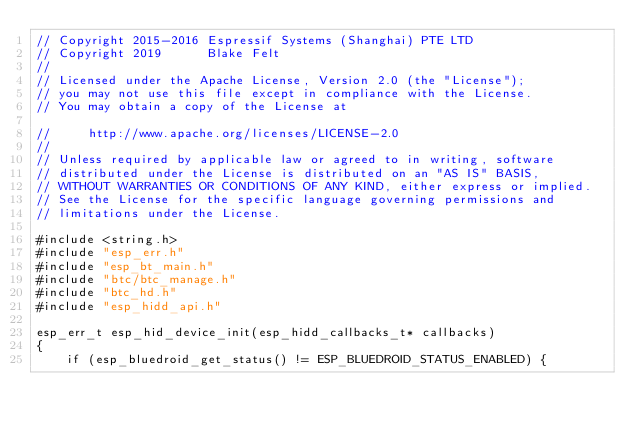Convert code to text. <code><loc_0><loc_0><loc_500><loc_500><_C_>// Copyright 2015-2016 Espressif Systems (Shanghai) PTE LTD
// Copyright 2019      Blake Felt
//
// Licensed under the Apache License, Version 2.0 (the "License");
// you may not use this file except in compliance with the License.
// You may obtain a copy of the License at

//     http://www.apache.org/licenses/LICENSE-2.0
//
// Unless required by applicable law or agreed to in writing, software
// distributed under the License is distributed on an "AS IS" BASIS,
// WITHOUT WARRANTIES OR CONDITIONS OF ANY KIND, either express or implied.
// See the License for the specific language governing permissions and
// limitations under the License.

#include <string.h>
#include "esp_err.h"
#include "esp_bt_main.h"
#include "btc/btc_manage.h"
#include "btc_hd.h"
#include "esp_hidd_api.h"

esp_err_t esp_hid_device_init(esp_hidd_callbacks_t* callbacks)
{
    if (esp_bluedroid_get_status() != ESP_BLUEDROID_STATUS_ENABLED) {</code> 